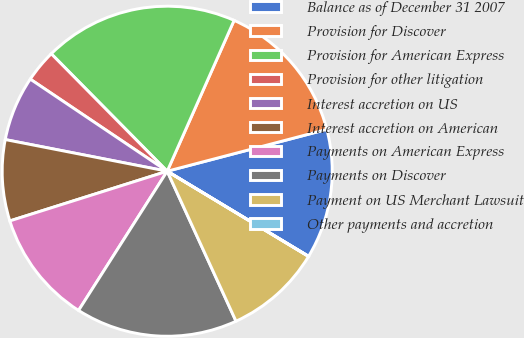Convert chart. <chart><loc_0><loc_0><loc_500><loc_500><pie_chart><fcel>Balance as of December 31 2007<fcel>Provision for Discover<fcel>Provision for American Express<fcel>Provision for other litigation<fcel>Interest accretion on US<fcel>Interest accretion on American<fcel>Payments on American Express<fcel>Payments on Discover<fcel>Payment on US Merchant Lawsuit<fcel>Other payments and accretion<nl><fcel>12.7%<fcel>14.28%<fcel>19.04%<fcel>3.18%<fcel>6.35%<fcel>7.94%<fcel>11.11%<fcel>15.87%<fcel>9.52%<fcel>0.01%<nl></chart> 